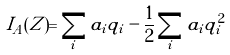Convert formula to latex. <formula><loc_0><loc_0><loc_500><loc_500>I _ { A } ( Z ) = \sum _ { i } a _ { i } q _ { i } - \frac { 1 } { 2 } \sum _ { i } a _ { i } q _ { i } ^ { 2 }</formula> 